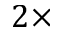Convert formula to latex. <formula><loc_0><loc_0><loc_500><loc_500>2 \times</formula> 